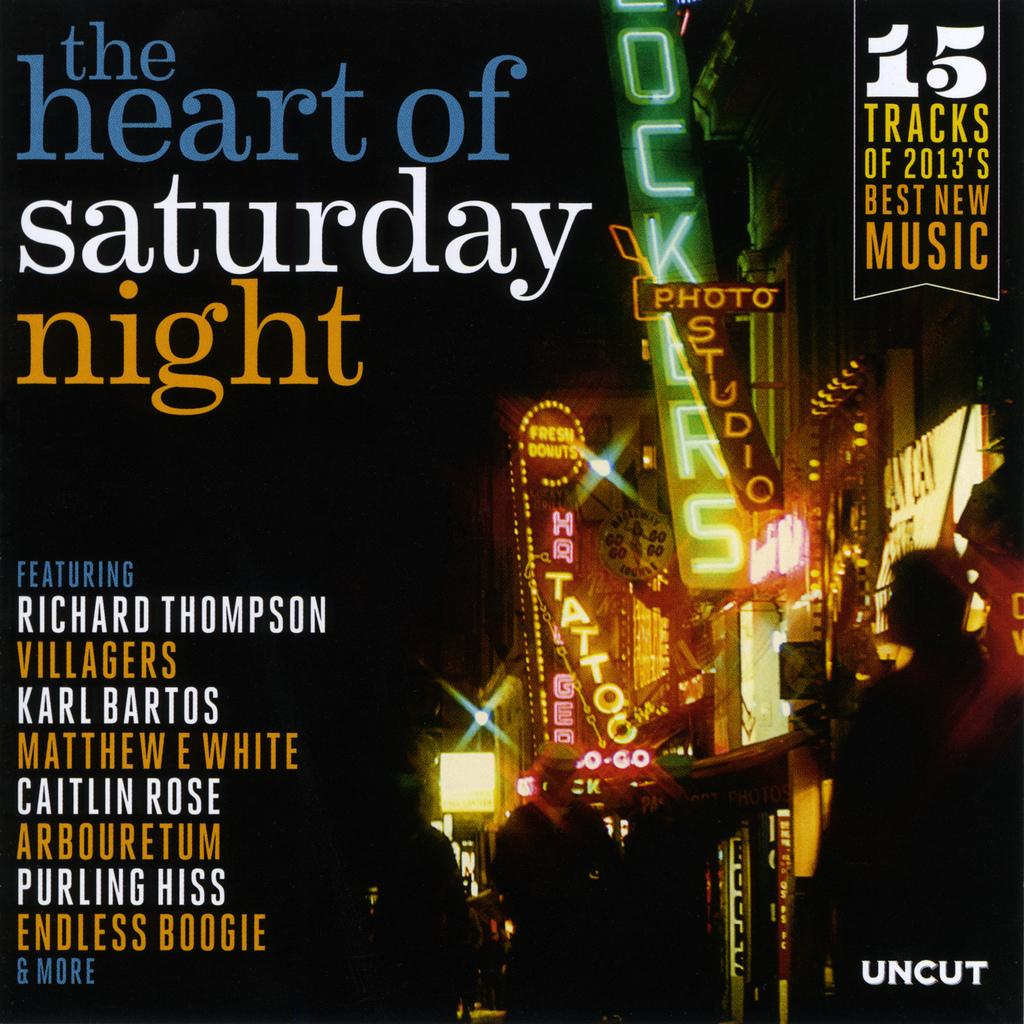<image>
Share a concise interpretation of the image provided. Cover that says Uncut on the bottom right and some names on the left. 